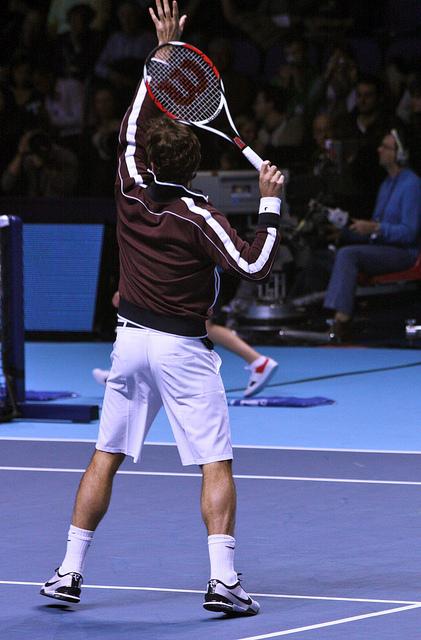Which brand is the racket?
Concise answer only. Wilson. Is this a man?
Quick response, please. Yes. Is this a young woman playing tennis?
Keep it brief. No. What brand is the racket?
Be succinct. Wilson. 